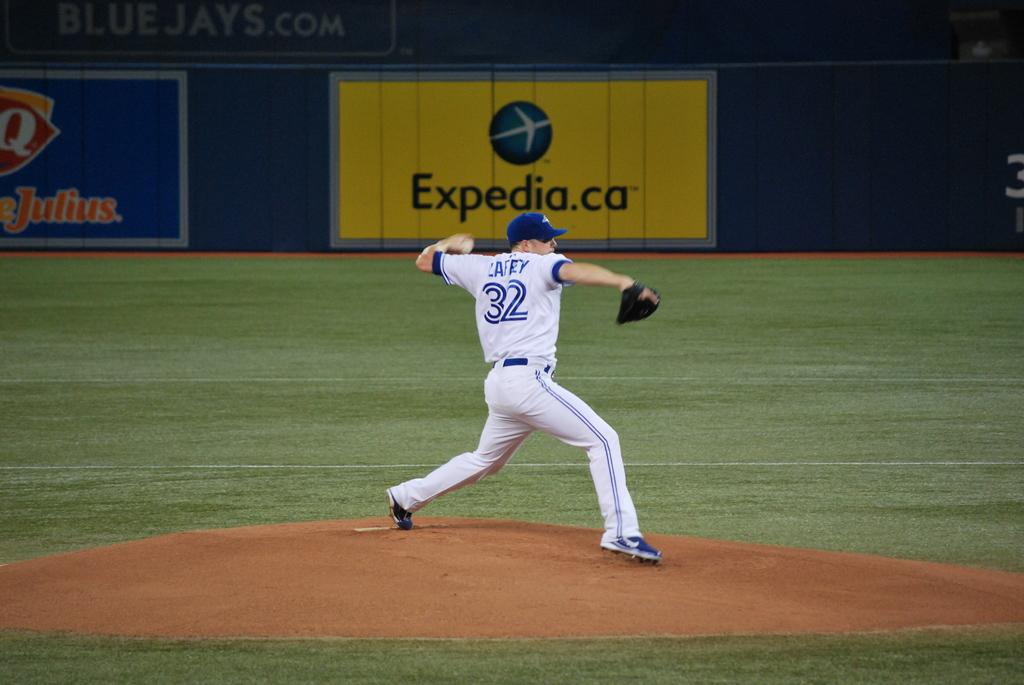<image>
Share a concise interpretation of the image provided. Number 32 in a white and blue trimmed uniform winding up for the pitch. 